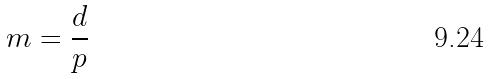<formula> <loc_0><loc_0><loc_500><loc_500>m = \frac { d } { p }</formula> 